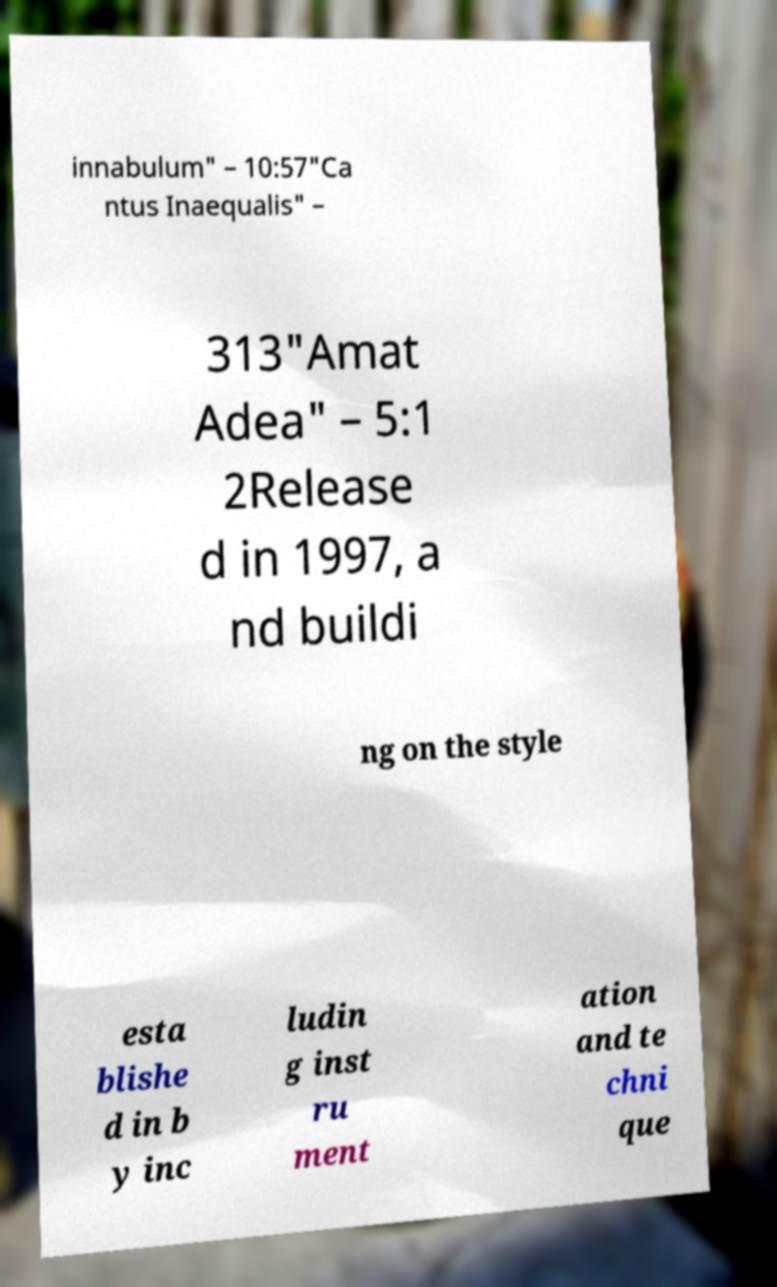Could you extract and type out the text from this image? innabulum" – 10:57"Ca ntus Inaequalis" – 313"Amat Adea" – 5:1 2Release d in 1997, a nd buildi ng on the style esta blishe d in b y inc ludin g inst ru ment ation and te chni que 